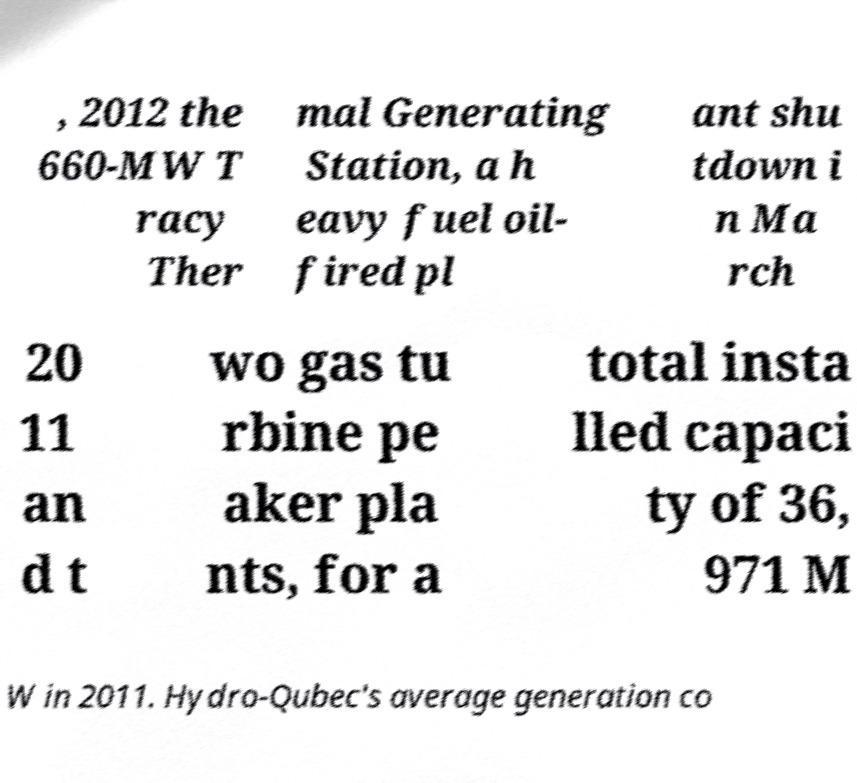What messages or text are displayed in this image? I need them in a readable, typed format. , 2012 the 660-MW T racy Ther mal Generating Station, a h eavy fuel oil- fired pl ant shu tdown i n Ma rch 20 11 an d t wo gas tu rbine pe aker pla nts, for a total insta lled capaci ty of 36, 971 M W in 2011. Hydro-Qubec's average generation co 